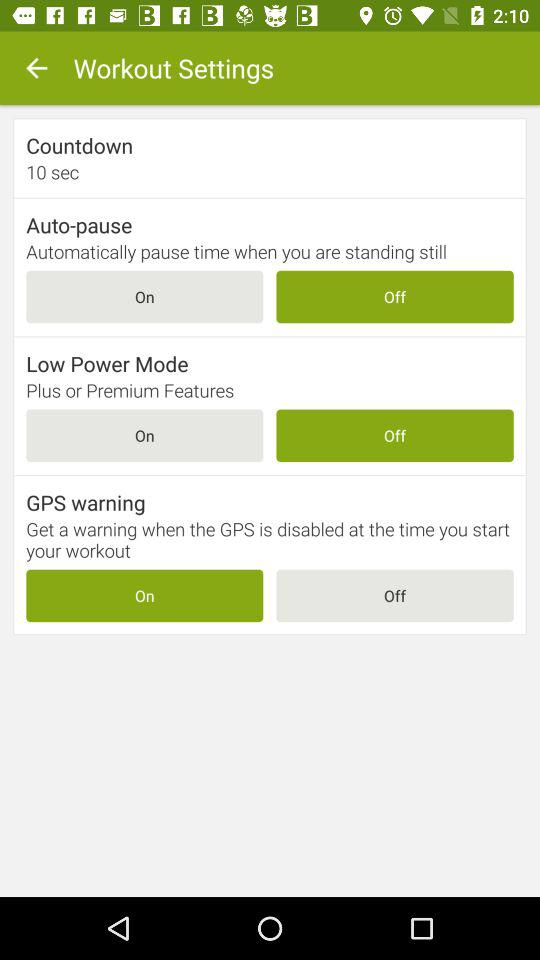What is the user's name?
When the provided information is insufficient, respond with <no answer>. <no answer> 